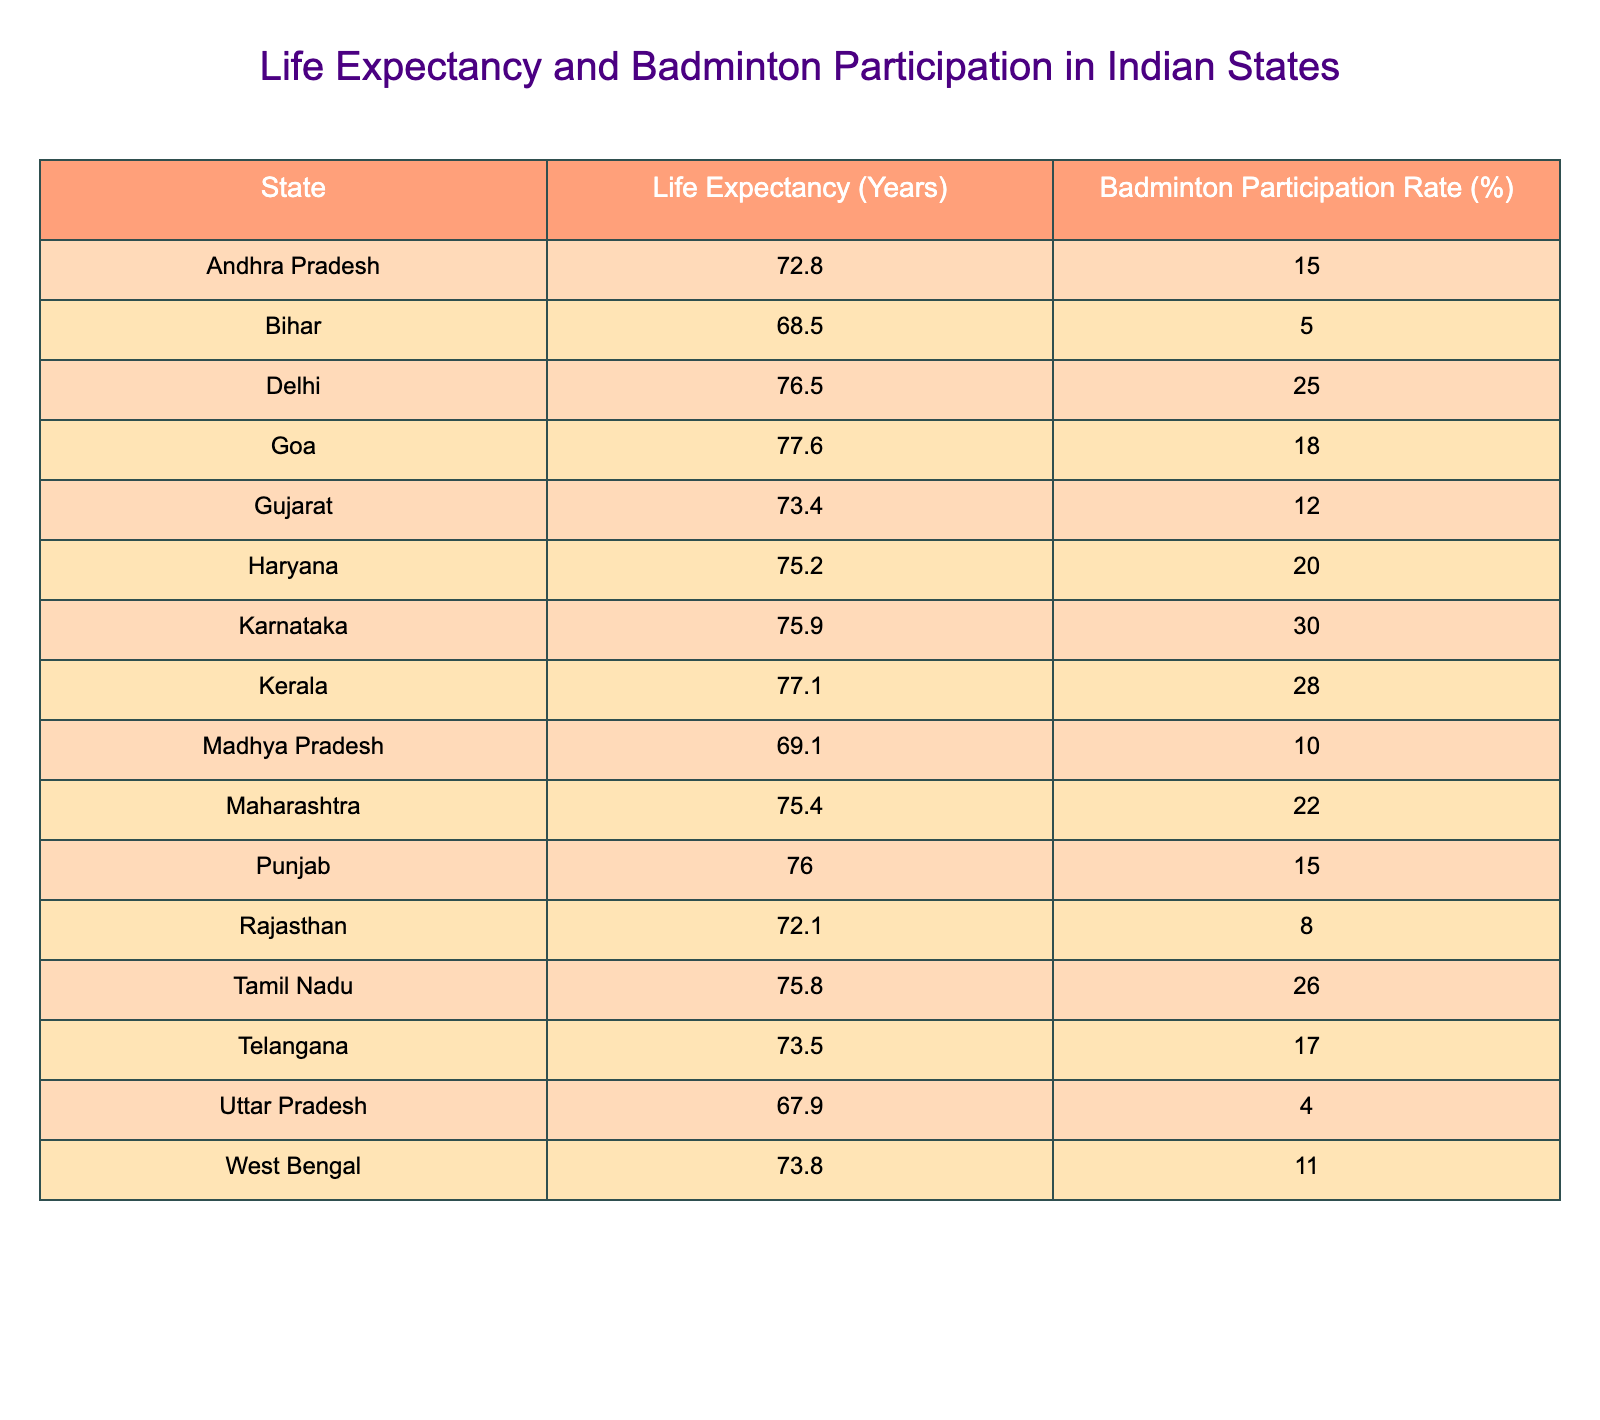What is the life expectancy in Karnataka? The table shows that the life expectancy in Karnataka is listed directly under the "Life Expectancy (Years)" column. By looking at the row for Karnataka, we find the value is 75.9 years.
Answer: 75.9 years Which state has the highest badminton participation rate? The table lists all states along with their badminton participation rates. By scanning the percentages in the "Badminton Participation Rate (%)" column, we see that Karnataka has the highest rate at 30%.
Answer: Karnataka Is the life expectancy in Uttar Pradesh greater than 70 years? We can find the life expectancy for Uttar Pradesh in the table, which shows it as 67.9 years. Since 67.9 is less than 70, the answer is no.
Answer: No What is the average life expectancy of states with a badminton participation rate over 20%? First, we identify the states with rates over 20%, which are Delhi, Karnataka, Kerala, and Tamil Nadu. Their respective life expectancies are 76.5, 75.9, 77.1, and 75.8 years. Adding these values gives 76.5 + 75.9 + 77.1 + 75.8 = 305.3 years. There are 4 states, so the average is 305.3 / 4 = 76.325 years.
Answer: 76.325 years Which state has a life expectancy lower than both Bihar and Madhya Pradesh? Looking at Bihar's life expectancy of 68.5 years and Madhya Pradesh's 69.1 years in the table, we search for any states with values less than both. We find that Uttar Pradesh has a life expectancy of 67.9 years, which is lower than both Bihar and Madhya Pradesh.
Answer: Uttar Pradesh How many states have a badminton participation rate between 10% and 20%? We scan the "Badminton Participation Rate (%)" column to count states with rates between 10% and 20%. These states are Telangana (17%), Andhra Pradesh (15%), Gujarat (12%), and West Bengal (11%). There are four states in total.
Answer: 4 states Are there any states where life expectancy is higher than 75 years with a participation rate below 20%? First, we find states with life expectancies above 75 years: Delhi (76.5), Goa (77.6), Haryana (75.2), Karnataka (75.9), and Kerala (77.1). Then, we check their badminton participation rates. Haryana (20%) just meets the threshold, while Delhi, Goa, Karnataka, and Kerala all have rates higher than 20%. Thus, the answer is no.
Answer: No What is the difference in life expectancy between Kerala and Uttar Pradesh? We first find the life expectancy for Kerala, which is 77.1 years, and for Uttar Pradesh, which is 67.9 years. By calculating the difference: 77.1 - 67.9 = 9.2 years, we find the difference in life expectancy.
Answer: 9.2 years Which state has a life expectancy closer to the average life expectancy of all states listed? To find this, we first calculate the average life expectancy from all the states. The total life expectancy is 72.8 + 68.5 + 76.5 + 77.6 + 73.4 + 75.2 + 75.9 + 77.1 + 69.1 + 75.4 + 76.0 + 72.1 + 75.8 + 73.5 + 67.9 + 73.8 = 1157.2 years for 16 states, giving an average of 1157.2 / 16 = 72.4 years. The life expectancy closest to this is Rajasthan at 72.1 years.
Answer: Rajasthan 